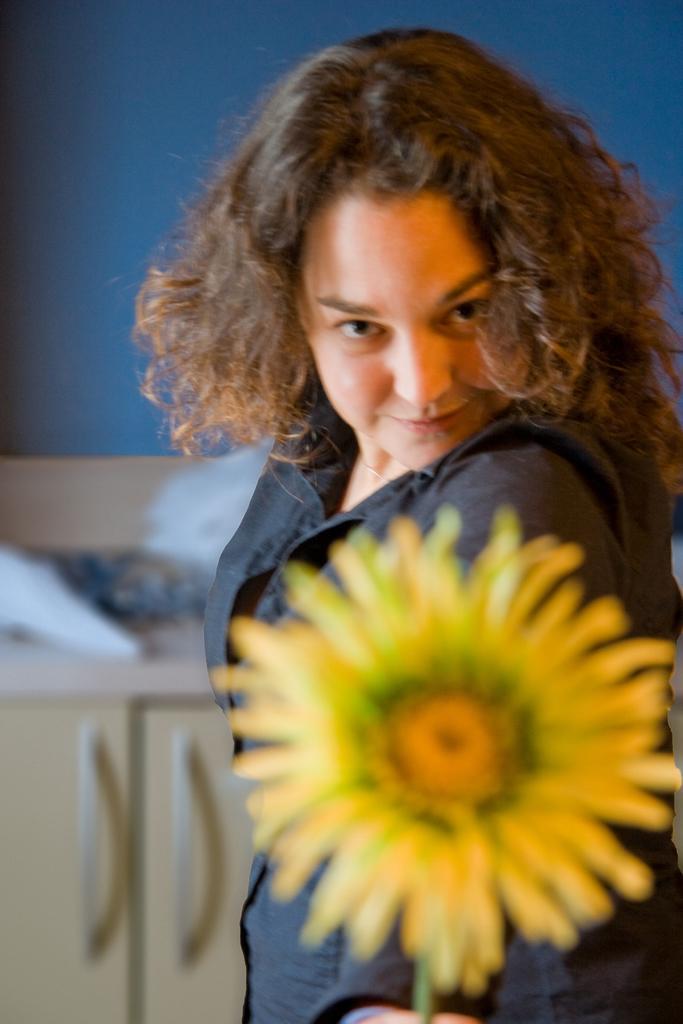Please provide a concise description of this image. In the picture I can see a woman wearing black dress is holding a sun flower in her hand and there is a table behind her which has few objects placed on it. 